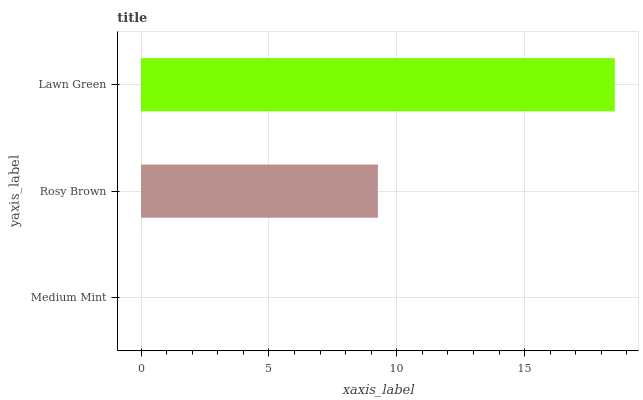Is Medium Mint the minimum?
Answer yes or no. Yes. Is Lawn Green the maximum?
Answer yes or no. Yes. Is Rosy Brown the minimum?
Answer yes or no. No. Is Rosy Brown the maximum?
Answer yes or no. No. Is Rosy Brown greater than Medium Mint?
Answer yes or no. Yes. Is Medium Mint less than Rosy Brown?
Answer yes or no. Yes. Is Medium Mint greater than Rosy Brown?
Answer yes or no. No. Is Rosy Brown less than Medium Mint?
Answer yes or no. No. Is Rosy Brown the high median?
Answer yes or no. Yes. Is Rosy Brown the low median?
Answer yes or no. Yes. Is Medium Mint the high median?
Answer yes or no. No. Is Lawn Green the low median?
Answer yes or no. No. 